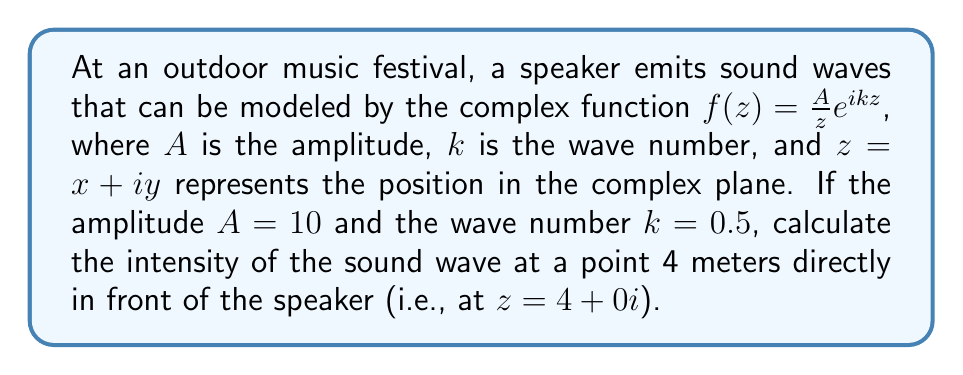Teach me how to tackle this problem. To solve this problem, we'll follow these steps:

1) The intensity of a sound wave is proportional to the square of its amplitude. For a spherical wave, the intensity $I$ at a distance $r$ from the source is given by:

   $I = \frac{|f(z)|^2}{r^2}$

2) In our case, $z = 4 + 0i = 4$, so $r = 4$.

3) We need to calculate $|f(4)|^2$:

   $f(4) = \frac{10}{4}e^{0.5 \cdot 4i} = \frac{5}{2}e^{2i}$

4) To find $|f(4)|$, we use the property $|e^{ix}| = 1$ for any real $x$:

   $|f(4)| = |\frac{5}{2}e^{2i}| = \frac{5}{2}|e^{2i}| = \frac{5}{2}$

5) Now we can calculate $|f(4)|^2$:

   $|f(4)|^2 = (\frac{5}{2})^2 = \frac{25}{4}$

6) Finally, we calculate the intensity:

   $I = \frac{|f(4)|^2}{r^2} = \frac{25/4}{4^2} = \frac{25}{64}$

Therefore, the intensity of the sound wave at the point 4 meters directly in front of the speaker is $\frac{25}{64}$ units.
Answer: $\frac{25}{64}$ 